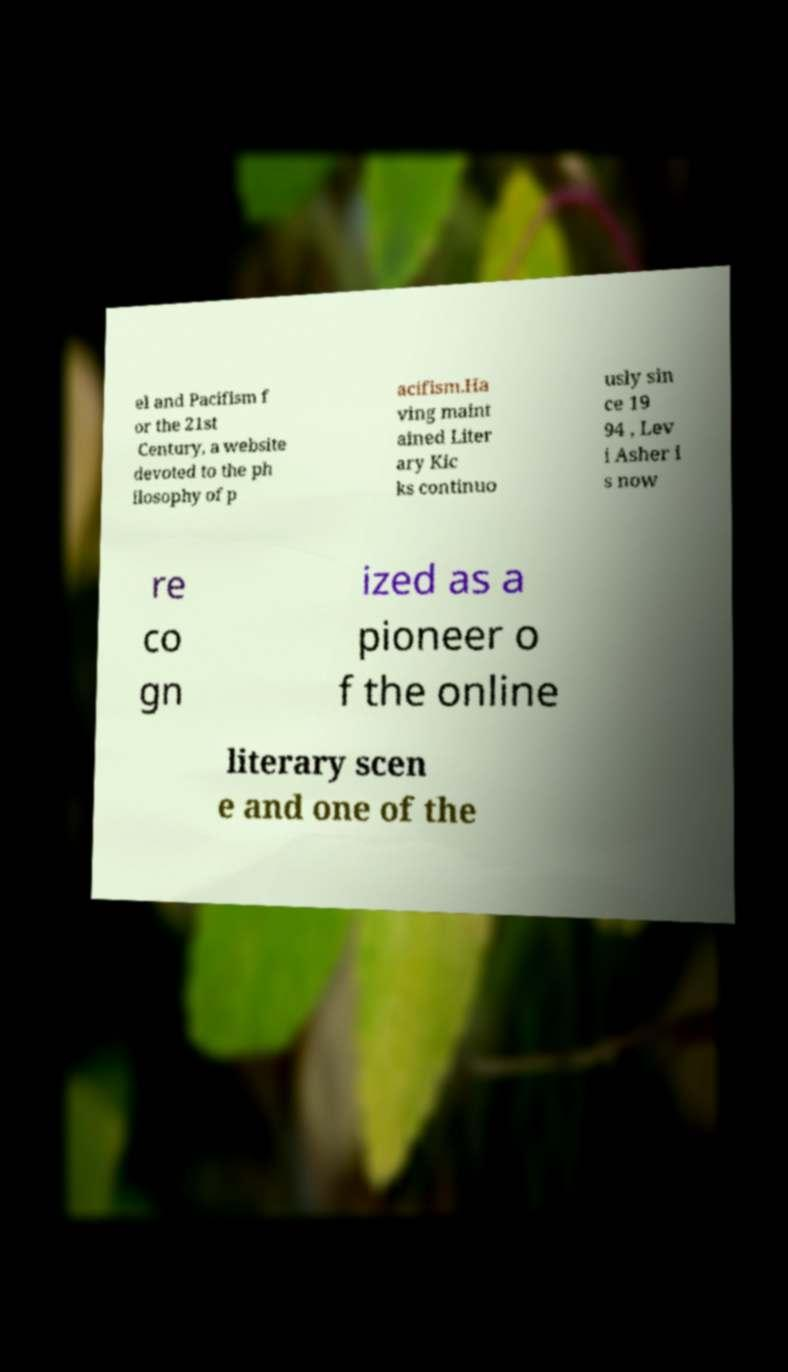What messages or text are displayed in this image? I need them in a readable, typed format. el and Pacifism f or the 21st Century, a website devoted to the ph ilosophy of p acifism.Ha ving maint ained Liter ary Kic ks continuo usly sin ce 19 94 , Lev i Asher i s now re co gn ized as a pioneer o f the online literary scen e and one of the 